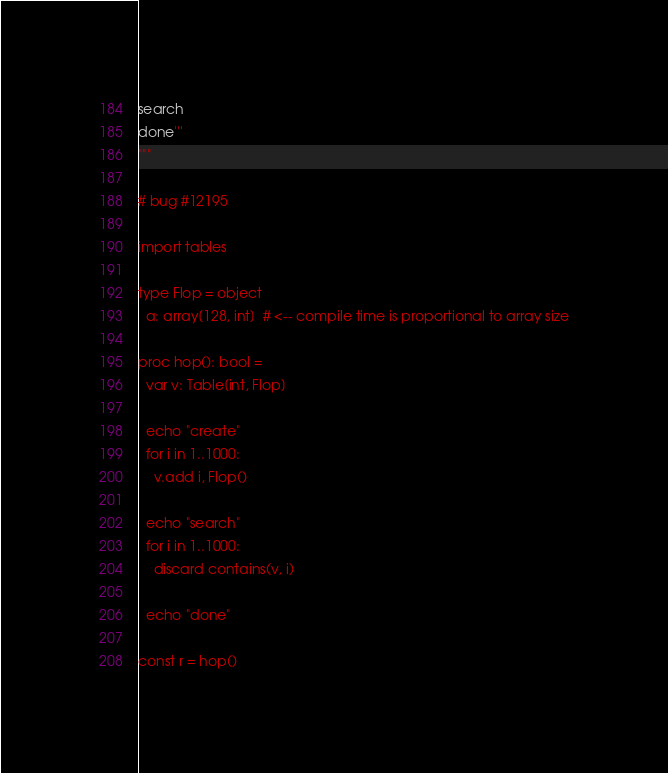<code> <loc_0><loc_0><loc_500><loc_500><_Nim_>search
done'''
"""

# bug #12195

import tables

type Flop = object
  a: array[128, int]  # <-- compile time is proportional to array size

proc hop(): bool =
  var v: Table[int, Flop]

  echo "create"
  for i in 1..1000:
    v.add i, Flop()

  echo "search"
  for i in 1..1000:
    discard contains(v, i)

  echo "done"

const r = hop()

</code> 